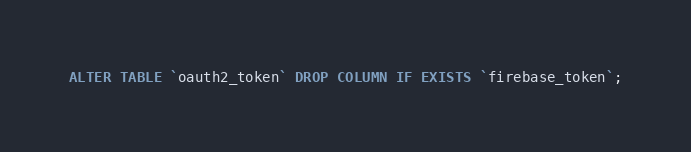Convert code to text. <code><loc_0><loc_0><loc_500><loc_500><_SQL_>ALTER TABLE `oauth2_token` DROP COLUMN IF EXISTS `firebase_token`;
</code> 